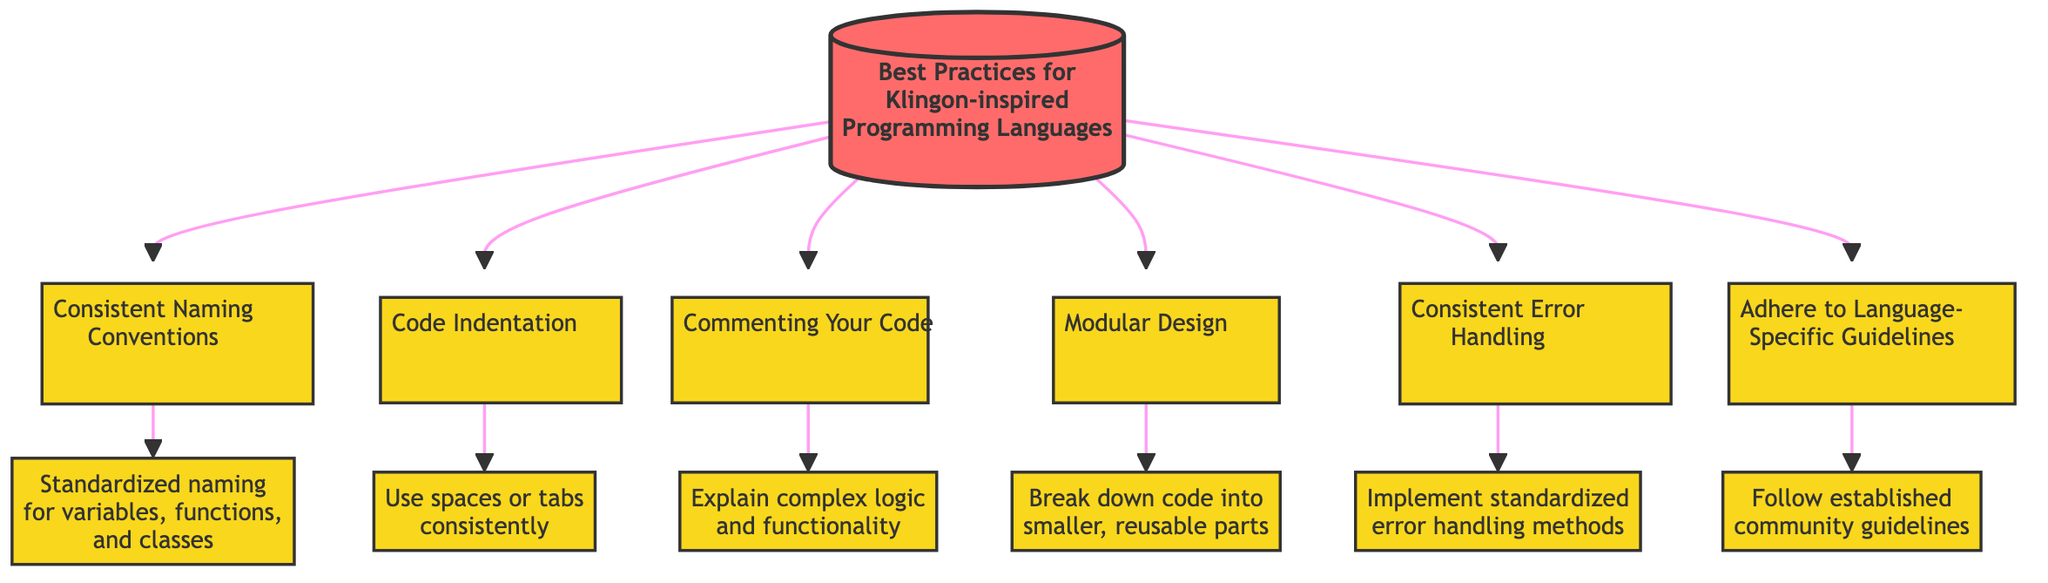What is the main title of this flow chart? The main title is prominently displayed at the top of the diagram, labeled as "Best Practices for Klingon-inspired Programming Languages."
Answer: Best Practices for Klingon-inspired Programming Languages How many main practices are listed in the diagram? The diagram includes six main practices branching from the title, specifically labeled as separate nodes.
Answer: 6 What does the first practice focus on? The first node listed under the title details "Consistent Naming Conventions," which emphasizes the importance of standardized naming conventions for variables, functions, and classes.
Answer: Consistent Naming Conventions Which practice is linked to the concept of modularity? The node under "Modular Design" addresses the idea of breaking down code into smaller, reusable functions or modules to enhance readability and maintainability.
Answer: Modular Design What is emphasized under "Consistent Error Handling"? The linked node specifies that it involves implementing standardized methods for error handling to improve reliability and debugging, reflecting its focus on error management.
Answer: Standardized methods for error handling Which practice mentions community guidelines? The node labeled "Adhere to Language-Specific Guidelines" indicates the importance of following established community guidelines and practices within Klingon-inspired languages.
Answer: Adhere to Language-Specific Guidelines What specific aspect does "Commenting Your Code" highlight? Under "Commenting Your Code," the diagram notes the importance of adding comments to explain complex logic and functionality, ensuring clarity and relevance.
Answer: Explain complex logic and functionality How do the practices flow from the title? All six practices branch from the main title node, indicating a structured flow in which each practice leads to its respective specifics, demonstrating the overall organization of the best practices.
Answer: Branch from the main title to specific practices 